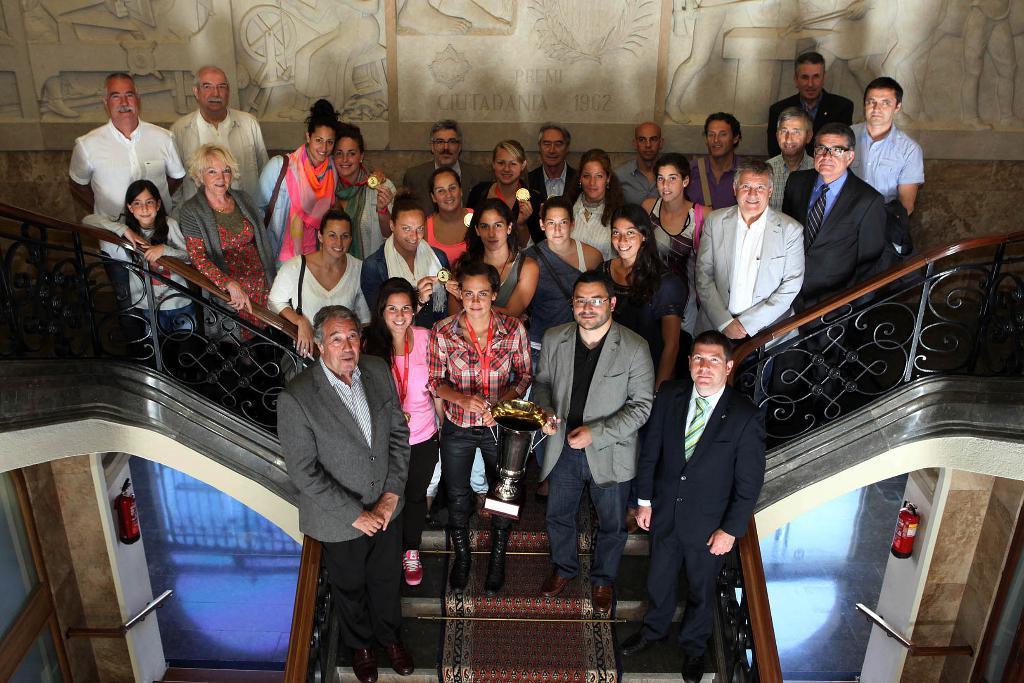Can you describe this image briefly? In this image I can see so many people standing on the stairs in which two of them holding momentum cup and some other holding badges, at the back there is a wall with some art in it. 